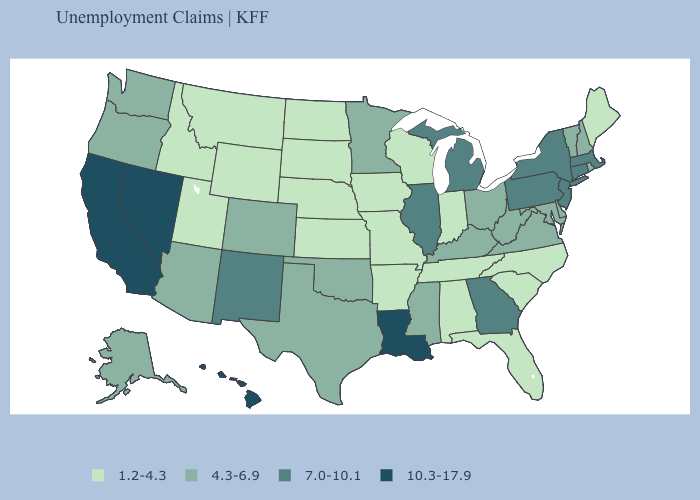Name the states that have a value in the range 7.0-10.1?
Concise answer only. Connecticut, Georgia, Illinois, Massachusetts, Michigan, New Jersey, New Mexico, New York, Pennsylvania. Does Illinois have the highest value in the MidWest?
Be succinct. Yes. What is the highest value in the Northeast ?
Keep it brief. 7.0-10.1. Name the states that have a value in the range 7.0-10.1?
Quick response, please. Connecticut, Georgia, Illinois, Massachusetts, Michigan, New Jersey, New Mexico, New York, Pennsylvania. What is the value of Oklahoma?
Answer briefly. 4.3-6.9. What is the value of West Virginia?
Quick response, please. 4.3-6.9. What is the highest value in states that border California?
Give a very brief answer. 10.3-17.9. Which states have the highest value in the USA?
Be succinct. California, Hawaii, Louisiana, Nevada. What is the lowest value in the Northeast?
Write a very short answer. 1.2-4.3. What is the value of South Carolina?
Concise answer only. 1.2-4.3. Among the states that border New Jersey , does Pennsylvania have the lowest value?
Be succinct. No. Name the states that have a value in the range 10.3-17.9?
Concise answer only. California, Hawaii, Louisiana, Nevada. Among the states that border Florida , which have the highest value?
Be succinct. Georgia. Does Illinois have the highest value in the MidWest?
Give a very brief answer. Yes. Does California have the highest value in the West?
Quick response, please. Yes. 